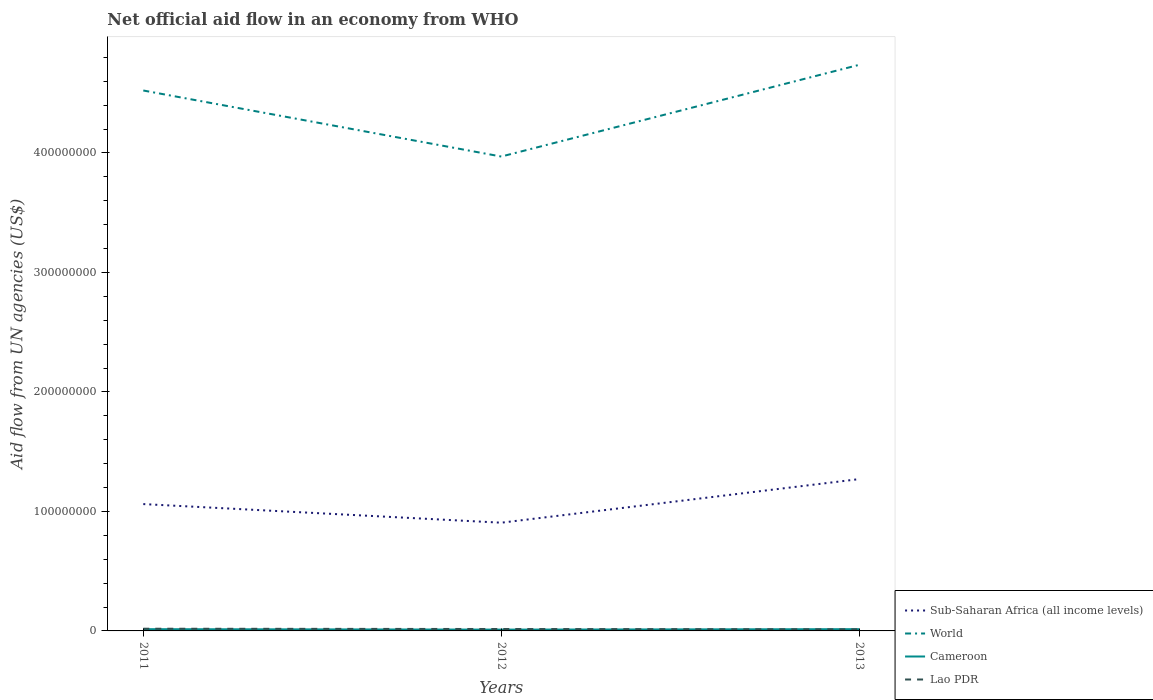Does the line corresponding to Cameroon intersect with the line corresponding to World?
Make the answer very short. No. Is the number of lines equal to the number of legend labels?
Provide a short and direct response. Yes. Across all years, what is the maximum net official aid flow in Lao PDR?
Ensure brevity in your answer.  1.33e+06. In which year was the net official aid flow in Sub-Saharan Africa (all income levels) maximum?
Give a very brief answer. 2012. What is the total net official aid flow in Lao PDR in the graph?
Give a very brief answer. 2.40e+05. What is the difference between the highest and the second highest net official aid flow in World?
Keep it short and to the point. 7.68e+07. Is the net official aid flow in Lao PDR strictly greater than the net official aid flow in World over the years?
Make the answer very short. Yes. How many years are there in the graph?
Provide a succinct answer. 3. Does the graph contain grids?
Make the answer very short. No. Where does the legend appear in the graph?
Keep it short and to the point. Bottom right. How many legend labels are there?
Ensure brevity in your answer.  4. What is the title of the graph?
Offer a terse response. Net official aid flow in an economy from WHO. Does "El Salvador" appear as one of the legend labels in the graph?
Keep it short and to the point. No. What is the label or title of the Y-axis?
Your answer should be very brief. Aid flow from UN agencies (US$). What is the Aid flow from UN agencies (US$) in Sub-Saharan Africa (all income levels) in 2011?
Offer a terse response. 1.06e+08. What is the Aid flow from UN agencies (US$) of World in 2011?
Your answer should be very brief. 4.52e+08. What is the Aid flow from UN agencies (US$) in Cameroon in 2011?
Make the answer very short. 1.46e+06. What is the Aid flow from UN agencies (US$) of Lao PDR in 2011?
Ensure brevity in your answer.  1.84e+06. What is the Aid flow from UN agencies (US$) in Sub-Saharan Africa (all income levels) in 2012?
Your answer should be very brief. 9.06e+07. What is the Aid flow from UN agencies (US$) of World in 2012?
Your answer should be compact. 3.97e+08. What is the Aid flow from UN agencies (US$) in Cameroon in 2012?
Your response must be concise. 1.10e+06. What is the Aid flow from UN agencies (US$) of Lao PDR in 2012?
Give a very brief answer. 1.60e+06. What is the Aid flow from UN agencies (US$) in Sub-Saharan Africa (all income levels) in 2013?
Your answer should be compact. 1.27e+08. What is the Aid flow from UN agencies (US$) of World in 2013?
Give a very brief answer. 4.74e+08. What is the Aid flow from UN agencies (US$) of Cameroon in 2013?
Keep it short and to the point. 1.46e+06. What is the Aid flow from UN agencies (US$) in Lao PDR in 2013?
Your answer should be very brief. 1.33e+06. Across all years, what is the maximum Aid flow from UN agencies (US$) in Sub-Saharan Africa (all income levels)?
Your response must be concise. 1.27e+08. Across all years, what is the maximum Aid flow from UN agencies (US$) of World?
Offer a very short reply. 4.74e+08. Across all years, what is the maximum Aid flow from UN agencies (US$) of Cameroon?
Provide a succinct answer. 1.46e+06. Across all years, what is the maximum Aid flow from UN agencies (US$) in Lao PDR?
Offer a very short reply. 1.84e+06. Across all years, what is the minimum Aid flow from UN agencies (US$) of Sub-Saharan Africa (all income levels)?
Keep it short and to the point. 9.06e+07. Across all years, what is the minimum Aid flow from UN agencies (US$) of World?
Keep it short and to the point. 3.97e+08. Across all years, what is the minimum Aid flow from UN agencies (US$) of Cameroon?
Keep it short and to the point. 1.10e+06. Across all years, what is the minimum Aid flow from UN agencies (US$) of Lao PDR?
Your answer should be very brief. 1.33e+06. What is the total Aid flow from UN agencies (US$) of Sub-Saharan Africa (all income levels) in the graph?
Provide a short and direct response. 3.24e+08. What is the total Aid flow from UN agencies (US$) of World in the graph?
Keep it short and to the point. 1.32e+09. What is the total Aid flow from UN agencies (US$) in Cameroon in the graph?
Provide a succinct answer. 4.02e+06. What is the total Aid flow from UN agencies (US$) in Lao PDR in the graph?
Keep it short and to the point. 4.77e+06. What is the difference between the Aid flow from UN agencies (US$) of Sub-Saharan Africa (all income levels) in 2011 and that in 2012?
Your answer should be very brief. 1.56e+07. What is the difference between the Aid flow from UN agencies (US$) in World in 2011 and that in 2012?
Ensure brevity in your answer.  5.53e+07. What is the difference between the Aid flow from UN agencies (US$) of Cameroon in 2011 and that in 2012?
Ensure brevity in your answer.  3.60e+05. What is the difference between the Aid flow from UN agencies (US$) in Sub-Saharan Africa (all income levels) in 2011 and that in 2013?
Ensure brevity in your answer.  -2.09e+07. What is the difference between the Aid flow from UN agencies (US$) in World in 2011 and that in 2013?
Provide a short and direct response. -2.15e+07. What is the difference between the Aid flow from UN agencies (US$) of Lao PDR in 2011 and that in 2013?
Ensure brevity in your answer.  5.10e+05. What is the difference between the Aid flow from UN agencies (US$) in Sub-Saharan Africa (all income levels) in 2012 and that in 2013?
Your answer should be compact. -3.65e+07. What is the difference between the Aid flow from UN agencies (US$) in World in 2012 and that in 2013?
Give a very brief answer. -7.68e+07. What is the difference between the Aid flow from UN agencies (US$) in Cameroon in 2012 and that in 2013?
Keep it short and to the point. -3.60e+05. What is the difference between the Aid flow from UN agencies (US$) of Sub-Saharan Africa (all income levels) in 2011 and the Aid flow from UN agencies (US$) of World in 2012?
Offer a very short reply. -2.91e+08. What is the difference between the Aid flow from UN agencies (US$) in Sub-Saharan Africa (all income levels) in 2011 and the Aid flow from UN agencies (US$) in Cameroon in 2012?
Your answer should be very brief. 1.05e+08. What is the difference between the Aid flow from UN agencies (US$) of Sub-Saharan Africa (all income levels) in 2011 and the Aid flow from UN agencies (US$) of Lao PDR in 2012?
Offer a very short reply. 1.05e+08. What is the difference between the Aid flow from UN agencies (US$) in World in 2011 and the Aid flow from UN agencies (US$) in Cameroon in 2012?
Offer a terse response. 4.51e+08. What is the difference between the Aid flow from UN agencies (US$) in World in 2011 and the Aid flow from UN agencies (US$) in Lao PDR in 2012?
Provide a short and direct response. 4.51e+08. What is the difference between the Aid flow from UN agencies (US$) in Sub-Saharan Africa (all income levels) in 2011 and the Aid flow from UN agencies (US$) in World in 2013?
Give a very brief answer. -3.68e+08. What is the difference between the Aid flow from UN agencies (US$) in Sub-Saharan Africa (all income levels) in 2011 and the Aid flow from UN agencies (US$) in Cameroon in 2013?
Give a very brief answer. 1.05e+08. What is the difference between the Aid flow from UN agencies (US$) in Sub-Saharan Africa (all income levels) in 2011 and the Aid flow from UN agencies (US$) in Lao PDR in 2013?
Your response must be concise. 1.05e+08. What is the difference between the Aid flow from UN agencies (US$) of World in 2011 and the Aid flow from UN agencies (US$) of Cameroon in 2013?
Give a very brief answer. 4.51e+08. What is the difference between the Aid flow from UN agencies (US$) of World in 2011 and the Aid flow from UN agencies (US$) of Lao PDR in 2013?
Offer a very short reply. 4.51e+08. What is the difference between the Aid flow from UN agencies (US$) in Sub-Saharan Africa (all income levels) in 2012 and the Aid flow from UN agencies (US$) in World in 2013?
Ensure brevity in your answer.  -3.83e+08. What is the difference between the Aid flow from UN agencies (US$) of Sub-Saharan Africa (all income levels) in 2012 and the Aid flow from UN agencies (US$) of Cameroon in 2013?
Ensure brevity in your answer.  8.91e+07. What is the difference between the Aid flow from UN agencies (US$) of Sub-Saharan Africa (all income levels) in 2012 and the Aid flow from UN agencies (US$) of Lao PDR in 2013?
Provide a short and direct response. 8.92e+07. What is the difference between the Aid flow from UN agencies (US$) in World in 2012 and the Aid flow from UN agencies (US$) in Cameroon in 2013?
Your answer should be very brief. 3.96e+08. What is the difference between the Aid flow from UN agencies (US$) in World in 2012 and the Aid flow from UN agencies (US$) in Lao PDR in 2013?
Provide a succinct answer. 3.96e+08. What is the average Aid flow from UN agencies (US$) in Sub-Saharan Africa (all income levels) per year?
Ensure brevity in your answer.  1.08e+08. What is the average Aid flow from UN agencies (US$) in World per year?
Keep it short and to the point. 4.41e+08. What is the average Aid flow from UN agencies (US$) of Cameroon per year?
Give a very brief answer. 1.34e+06. What is the average Aid flow from UN agencies (US$) of Lao PDR per year?
Offer a very short reply. 1.59e+06. In the year 2011, what is the difference between the Aid flow from UN agencies (US$) in Sub-Saharan Africa (all income levels) and Aid flow from UN agencies (US$) in World?
Your answer should be compact. -3.46e+08. In the year 2011, what is the difference between the Aid flow from UN agencies (US$) of Sub-Saharan Africa (all income levels) and Aid flow from UN agencies (US$) of Cameroon?
Provide a succinct answer. 1.05e+08. In the year 2011, what is the difference between the Aid flow from UN agencies (US$) in Sub-Saharan Africa (all income levels) and Aid flow from UN agencies (US$) in Lao PDR?
Provide a succinct answer. 1.04e+08. In the year 2011, what is the difference between the Aid flow from UN agencies (US$) in World and Aid flow from UN agencies (US$) in Cameroon?
Offer a terse response. 4.51e+08. In the year 2011, what is the difference between the Aid flow from UN agencies (US$) in World and Aid flow from UN agencies (US$) in Lao PDR?
Give a very brief answer. 4.50e+08. In the year 2011, what is the difference between the Aid flow from UN agencies (US$) in Cameroon and Aid flow from UN agencies (US$) in Lao PDR?
Your response must be concise. -3.80e+05. In the year 2012, what is the difference between the Aid flow from UN agencies (US$) in Sub-Saharan Africa (all income levels) and Aid flow from UN agencies (US$) in World?
Your response must be concise. -3.06e+08. In the year 2012, what is the difference between the Aid flow from UN agencies (US$) of Sub-Saharan Africa (all income levels) and Aid flow from UN agencies (US$) of Cameroon?
Your answer should be very brief. 8.95e+07. In the year 2012, what is the difference between the Aid flow from UN agencies (US$) in Sub-Saharan Africa (all income levels) and Aid flow from UN agencies (US$) in Lao PDR?
Make the answer very short. 8.90e+07. In the year 2012, what is the difference between the Aid flow from UN agencies (US$) of World and Aid flow from UN agencies (US$) of Cameroon?
Your answer should be very brief. 3.96e+08. In the year 2012, what is the difference between the Aid flow from UN agencies (US$) in World and Aid flow from UN agencies (US$) in Lao PDR?
Your answer should be very brief. 3.95e+08. In the year 2012, what is the difference between the Aid flow from UN agencies (US$) in Cameroon and Aid flow from UN agencies (US$) in Lao PDR?
Make the answer very short. -5.00e+05. In the year 2013, what is the difference between the Aid flow from UN agencies (US$) in Sub-Saharan Africa (all income levels) and Aid flow from UN agencies (US$) in World?
Your answer should be compact. -3.47e+08. In the year 2013, what is the difference between the Aid flow from UN agencies (US$) in Sub-Saharan Africa (all income levels) and Aid flow from UN agencies (US$) in Cameroon?
Your answer should be very brief. 1.26e+08. In the year 2013, what is the difference between the Aid flow from UN agencies (US$) of Sub-Saharan Africa (all income levels) and Aid flow from UN agencies (US$) of Lao PDR?
Ensure brevity in your answer.  1.26e+08. In the year 2013, what is the difference between the Aid flow from UN agencies (US$) in World and Aid flow from UN agencies (US$) in Cameroon?
Your answer should be very brief. 4.72e+08. In the year 2013, what is the difference between the Aid flow from UN agencies (US$) of World and Aid flow from UN agencies (US$) of Lao PDR?
Keep it short and to the point. 4.72e+08. In the year 2013, what is the difference between the Aid flow from UN agencies (US$) in Cameroon and Aid flow from UN agencies (US$) in Lao PDR?
Ensure brevity in your answer.  1.30e+05. What is the ratio of the Aid flow from UN agencies (US$) of Sub-Saharan Africa (all income levels) in 2011 to that in 2012?
Keep it short and to the point. 1.17. What is the ratio of the Aid flow from UN agencies (US$) of World in 2011 to that in 2012?
Your answer should be very brief. 1.14. What is the ratio of the Aid flow from UN agencies (US$) in Cameroon in 2011 to that in 2012?
Your answer should be very brief. 1.33. What is the ratio of the Aid flow from UN agencies (US$) of Lao PDR in 2011 to that in 2012?
Your answer should be very brief. 1.15. What is the ratio of the Aid flow from UN agencies (US$) in Sub-Saharan Africa (all income levels) in 2011 to that in 2013?
Your answer should be compact. 0.84. What is the ratio of the Aid flow from UN agencies (US$) of World in 2011 to that in 2013?
Ensure brevity in your answer.  0.95. What is the ratio of the Aid flow from UN agencies (US$) of Cameroon in 2011 to that in 2013?
Provide a succinct answer. 1. What is the ratio of the Aid flow from UN agencies (US$) in Lao PDR in 2011 to that in 2013?
Keep it short and to the point. 1.38. What is the ratio of the Aid flow from UN agencies (US$) in Sub-Saharan Africa (all income levels) in 2012 to that in 2013?
Offer a terse response. 0.71. What is the ratio of the Aid flow from UN agencies (US$) of World in 2012 to that in 2013?
Make the answer very short. 0.84. What is the ratio of the Aid flow from UN agencies (US$) in Cameroon in 2012 to that in 2013?
Make the answer very short. 0.75. What is the ratio of the Aid flow from UN agencies (US$) of Lao PDR in 2012 to that in 2013?
Give a very brief answer. 1.2. What is the difference between the highest and the second highest Aid flow from UN agencies (US$) in Sub-Saharan Africa (all income levels)?
Make the answer very short. 2.09e+07. What is the difference between the highest and the second highest Aid flow from UN agencies (US$) in World?
Your answer should be very brief. 2.15e+07. What is the difference between the highest and the second highest Aid flow from UN agencies (US$) of Cameroon?
Offer a very short reply. 0. What is the difference between the highest and the second highest Aid flow from UN agencies (US$) of Lao PDR?
Keep it short and to the point. 2.40e+05. What is the difference between the highest and the lowest Aid flow from UN agencies (US$) in Sub-Saharan Africa (all income levels)?
Your response must be concise. 3.65e+07. What is the difference between the highest and the lowest Aid flow from UN agencies (US$) in World?
Offer a terse response. 7.68e+07. What is the difference between the highest and the lowest Aid flow from UN agencies (US$) in Lao PDR?
Your answer should be compact. 5.10e+05. 